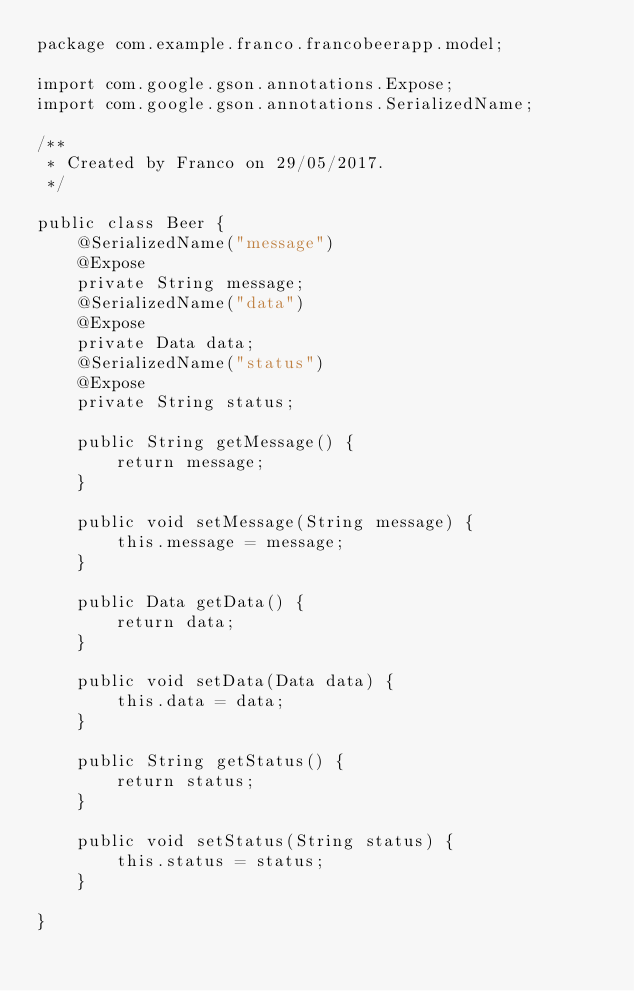<code> <loc_0><loc_0><loc_500><loc_500><_Java_>package com.example.franco.francobeerapp.model;

import com.google.gson.annotations.Expose;
import com.google.gson.annotations.SerializedName;

/**
 * Created by Franco on 29/05/2017.
 */

public class Beer {
    @SerializedName("message")
    @Expose
    private String message;
    @SerializedName("data")
    @Expose
    private Data data;
    @SerializedName("status")
    @Expose
    private String status;

    public String getMessage() {
        return message;
    }

    public void setMessage(String message) {
        this.message = message;
    }

    public Data getData() {
        return data;
    }

    public void setData(Data data) {
        this.data = data;
    }

    public String getStatus() {
        return status;
    }

    public void setStatus(String status) {
        this.status = status;
    }

}</code> 